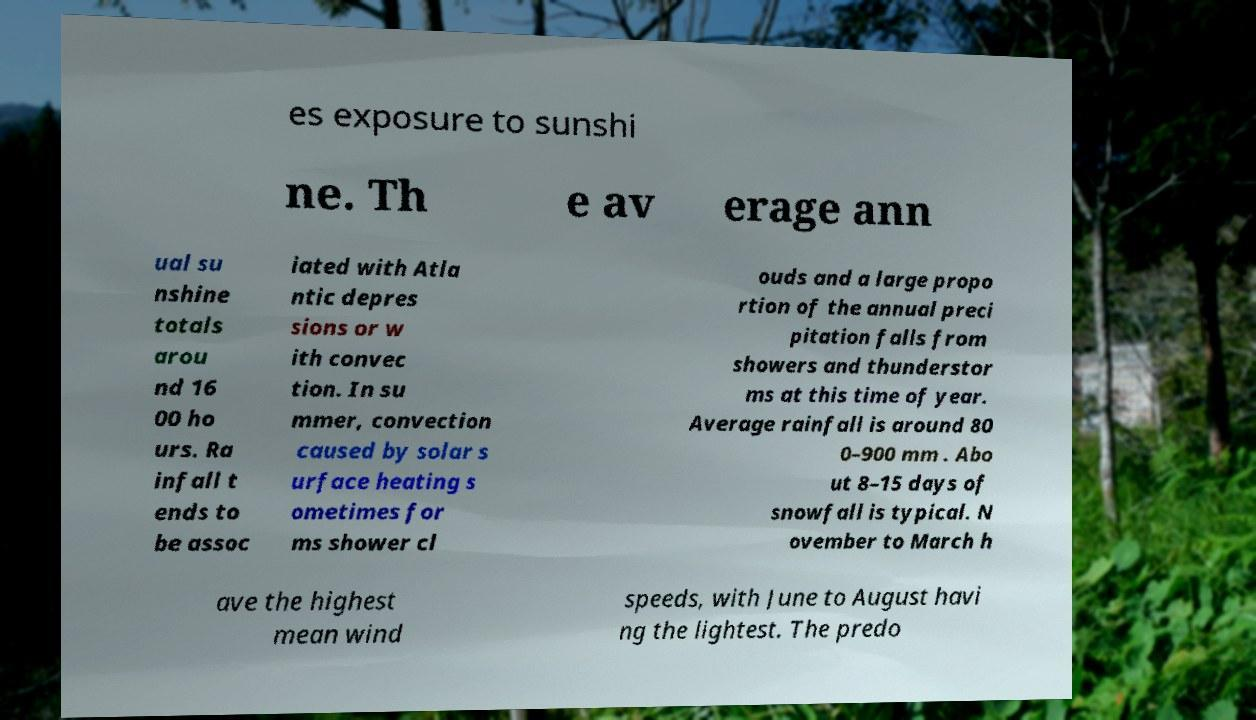For documentation purposes, I need the text within this image transcribed. Could you provide that? es exposure to sunshi ne. Th e av erage ann ual su nshine totals arou nd 16 00 ho urs. Ra infall t ends to be assoc iated with Atla ntic depres sions or w ith convec tion. In su mmer, convection caused by solar s urface heating s ometimes for ms shower cl ouds and a large propo rtion of the annual preci pitation falls from showers and thunderstor ms at this time of year. Average rainfall is around 80 0–900 mm . Abo ut 8–15 days of snowfall is typical. N ovember to March h ave the highest mean wind speeds, with June to August havi ng the lightest. The predo 